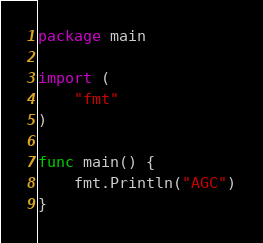Convert code to text. <code><loc_0><loc_0><loc_500><loc_500><_Go_>package main

import (
	"fmt"
)

func main() {
	fmt.Println("AGC")
}
</code> 